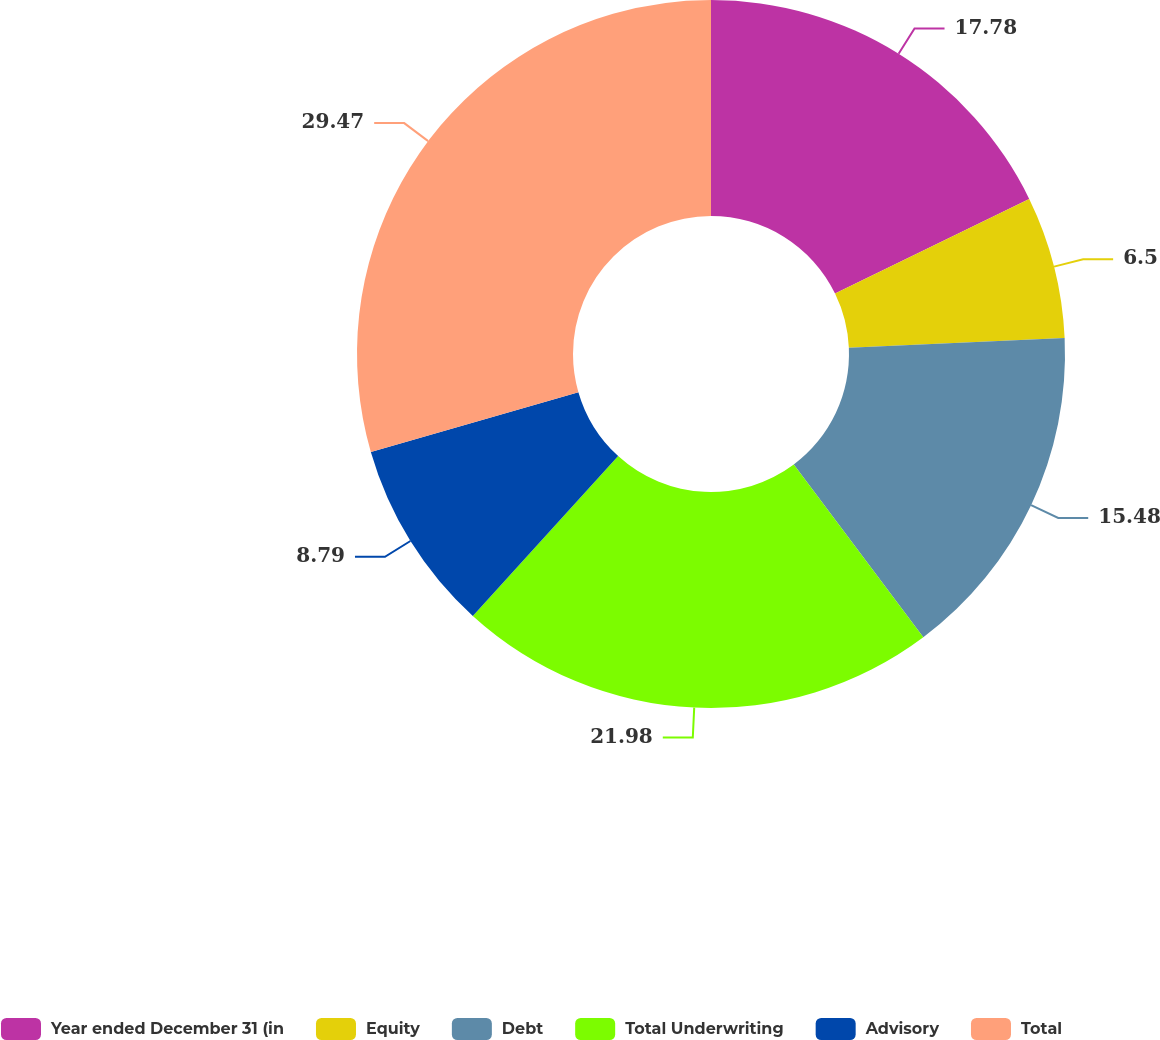Convert chart. <chart><loc_0><loc_0><loc_500><loc_500><pie_chart><fcel>Year ended December 31 (in<fcel>Equity<fcel>Debt<fcel>Total Underwriting<fcel>Advisory<fcel>Total<nl><fcel>17.78%<fcel>6.5%<fcel>15.48%<fcel>21.98%<fcel>8.79%<fcel>29.46%<nl></chart> 